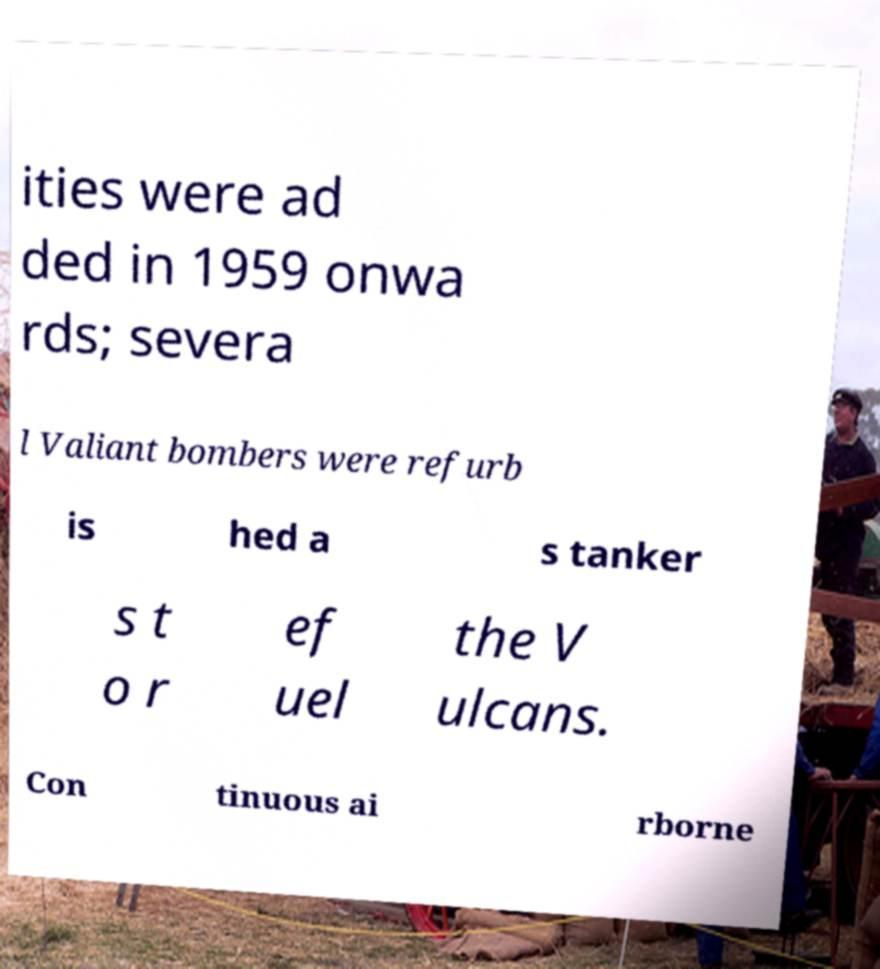Can you read and provide the text displayed in the image?This photo seems to have some interesting text. Can you extract and type it out for me? ities were ad ded in 1959 onwa rds; severa l Valiant bombers were refurb is hed a s tanker s t o r ef uel the V ulcans. Con tinuous ai rborne 